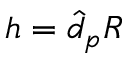Convert formula to latex. <formula><loc_0><loc_0><loc_500><loc_500>h = \hat { d } _ { p } R</formula> 